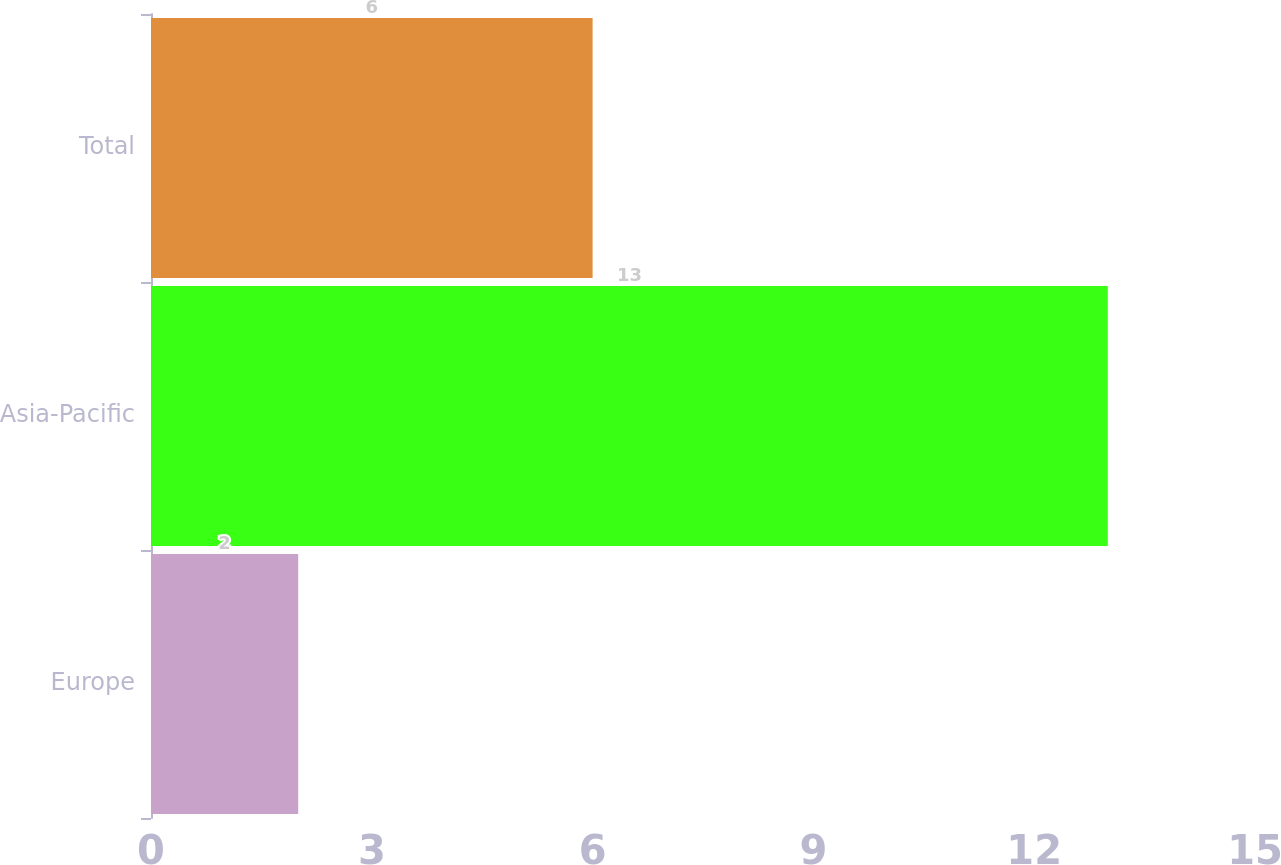Convert chart. <chart><loc_0><loc_0><loc_500><loc_500><bar_chart><fcel>Europe<fcel>Asia-Pacific<fcel>Total<nl><fcel>2<fcel>13<fcel>6<nl></chart> 